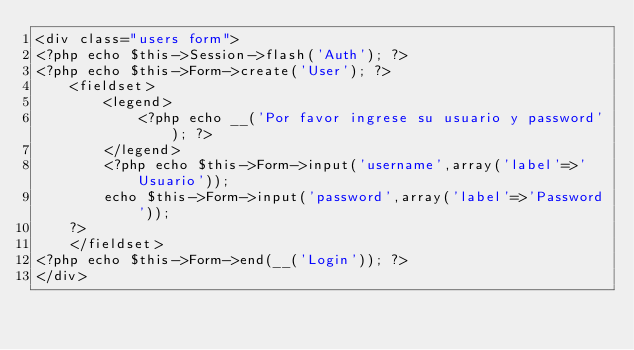Convert code to text. <code><loc_0><loc_0><loc_500><loc_500><_PHP_><div class="users form">
<?php echo $this->Session->flash('Auth'); ?>
<?php echo $this->Form->create('User'); ?>
    <fieldset>
        <legend>
            <?php echo __('Por favor ingrese su usuario y password'); ?>
        </legend>
        <?php echo $this->Form->input('username',array('label'=>'Usuario'));
        echo $this->Form->input('password',array('label'=>'Password'));
    ?>
    </fieldset>
<?php echo $this->Form->end(__('Login')); ?>
</div></code> 